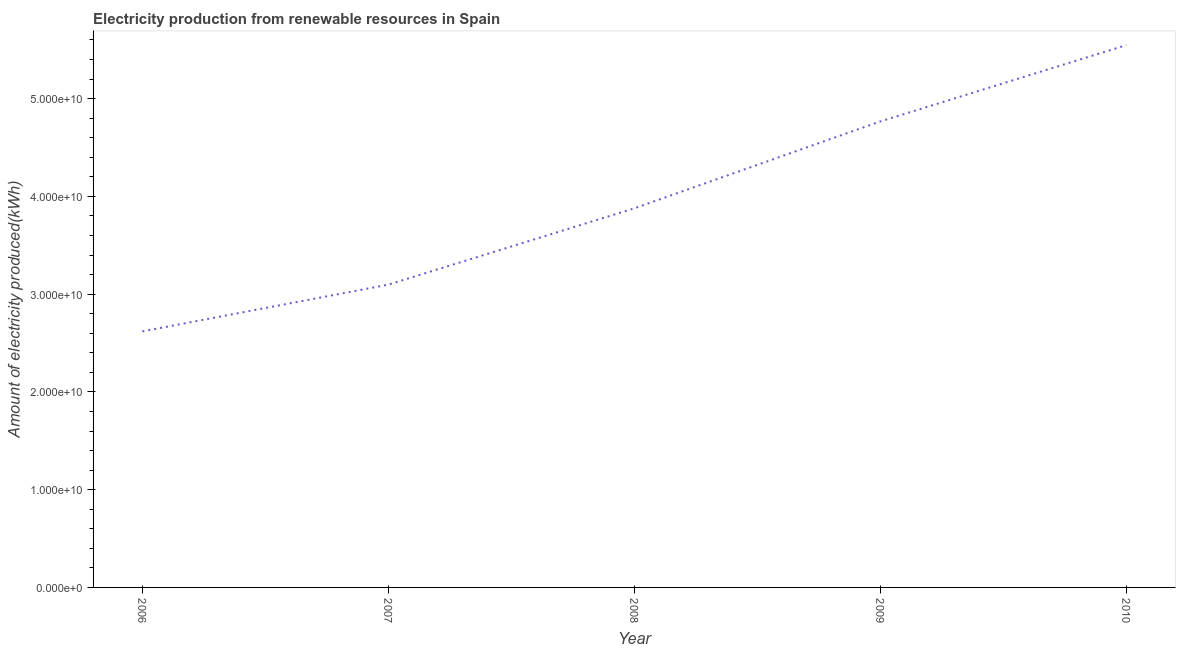What is the amount of electricity produced in 2010?
Your answer should be compact. 5.55e+1. Across all years, what is the maximum amount of electricity produced?
Offer a terse response. 5.55e+1. Across all years, what is the minimum amount of electricity produced?
Make the answer very short. 2.62e+1. In which year was the amount of electricity produced maximum?
Provide a short and direct response. 2010. In which year was the amount of electricity produced minimum?
Ensure brevity in your answer.  2006. What is the sum of the amount of electricity produced?
Give a very brief answer. 1.99e+11. What is the difference between the amount of electricity produced in 2007 and 2010?
Offer a terse response. -2.45e+1. What is the average amount of electricity produced per year?
Provide a succinct answer. 3.98e+1. What is the median amount of electricity produced?
Your response must be concise. 3.88e+1. In how many years, is the amount of electricity produced greater than 26000000000 kWh?
Offer a very short reply. 5. What is the ratio of the amount of electricity produced in 2008 to that in 2010?
Provide a short and direct response. 0.7. What is the difference between the highest and the second highest amount of electricity produced?
Provide a short and direct response. 7.80e+09. What is the difference between the highest and the lowest amount of electricity produced?
Your answer should be very brief. 2.93e+1. In how many years, is the amount of electricity produced greater than the average amount of electricity produced taken over all years?
Offer a terse response. 2. How many years are there in the graph?
Keep it short and to the point. 5. Are the values on the major ticks of Y-axis written in scientific E-notation?
Offer a very short reply. Yes. Does the graph contain any zero values?
Ensure brevity in your answer.  No. Does the graph contain grids?
Your answer should be very brief. No. What is the title of the graph?
Your answer should be compact. Electricity production from renewable resources in Spain. What is the label or title of the X-axis?
Offer a terse response. Year. What is the label or title of the Y-axis?
Provide a short and direct response. Amount of electricity produced(kWh). What is the Amount of electricity produced(kWh) of 2006?
Keep it short and to the point. 2.62e+1. What is the Amount of electricity produced(kWh) in 2007?
Make the answer very short. 3.10e+1. What is the Amount of electricity produced(kWh) in 2008?
Your answer should be very brief. 3.88e+1. What is the Amount of electricity produced(kWh) in 2009?
Offer a terse response. 4.77e+1. What is the Amount of electricity produced(kWh) in 2010?
Provide a short and direct response. 5.55e+1. What is the difference between the Amount of electricity produced(kWh) in 2006 and 2007?
Your answer should be very brief. -4.78e+09. What is the difference between the Amount of electricity produced(kWh) in 2006 and 2008?
Your answer should be compact. -1.26e+1. What is the difference between the Amount of electricity produced(kWh) in 2006 and 2009?
Offer a very short reply. -2.15e+1. What is the difference between the Amount of electricity produced(kWh) in 2006 and 2010?
Give a very brief answer. -2.93e+1. What is the difference between the Amount of electricity produced(kWh) in 2007 and 2008?
Offer a terse response. -7.80e+09. What is the difference between the Amount of electricity produced(kWh) in 2007 and 2009?
Provide a succinct answer. -1.67e+1. What is the difference between the Amount of electricity produced(kWh) in 2007 and 2010?
Ensure brevity in your answer.  -2.45e+1. What is the difference between the Amount of electricity produced(kWh) in 2008 and 2009?
Your response must be concise. -8.89e+09. What is the difference between the Amount of electricity produced(kWh) in 2008 and 2010?
Your response must be concise. -1.67e+1. What is the difference between the Amount of electricity produced(kWh) in 2009 and 2010?
Provide a succinct answer. -7.80e+09. What is the ratio of the Amount of electricity produced(kWh) in 2006 to that in 2007?
Your answer should be compact. 0.85. What is the ratio of the Amount of electricity produced(kWh) in 2006 to that in 2008?
Offer a terse response. 0.68. What is the ratio of the Amount of electricity produced(kWh) in 2006 to that in 2009?
Your answer should be very brief. 0.55. What is the ratio of the Amount of electricity produced(kWh) in 2006 to that in 2010?
Keep it short and to the point. 0.47. What is the ratio of the Amount of electricity produced(kWh) in 2007 to that in 2008?
Your response must be concise. 0.8. What is the ratio of the Amount of electricity produced(kWh) in 2007 to that in 2009?
Keep it short and to the point. 0.65. What is the ratio of the Amount of electricity produced(kWh) in 2007 to that in 2010?
Provide a succinct answer. 0.56. What is the ratio of the Amount of electricity produced(kWh) in 2008 to that in 2009?
Give a very brief answer. 0.81. What is the ratio of the Amount of electricity produced(kWh) in 2008 to that in 2010?
Your answer should be very brief. 0.7. What is the ratio of the Amount of electricity produced(kWh) in 2009 to that in 2010?
Give a very brief answer. 0.86. 